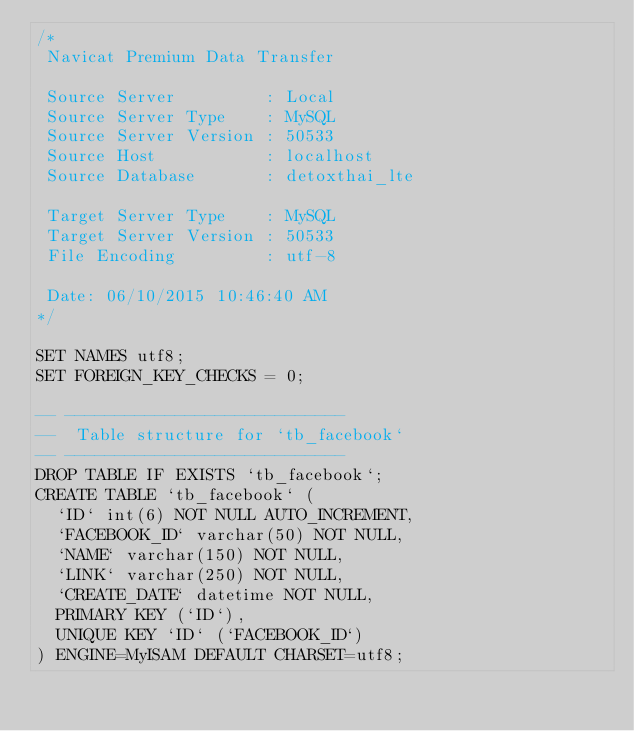<code> <loc_0><loc_0><loc_500><loc_500><_SQL_>/*
 Navicat Premium Data Transfer

 Source Server         : Local
 Source Server Type    : MySQL
 Source Server Version : 50533
 Source Host           : localhost
 Source Database       : detoxthai_lte

 Target Server Type    : MySQL
 Target Server Version : 50533
 File Encoding         : utf-8

 Date: 06/10/2015 10:46:40 AM
*/

SET NAMES utf8;
SET FOREIGN_KEY_CHECKS = 0;

-- ----------------------------
--  Table structure for `tb_facebook`
-- ----------------------------
DROP TABLE IF EXISTS `tb_facebook`;
CREATE TABLE `tb_facebook` (
  `ID` int(6) NOT NULL AUTO_INCREMENT,
  `FACEBOOK_ID` varchar(50) NOT NULL,
  `NAME` varchar(150) NOT NULL,
  `LINK` varchar(250) NOT NULL,
  `CREATE_DATE` datetime NOT NULL,
  PRIMARY KEY (`ID`),
  UNIQUE KEY `ID` (`FACEBOOK_ID`)
) ENGINE=MyISAM DEFAULT CHARSET=utf8;

</code> 